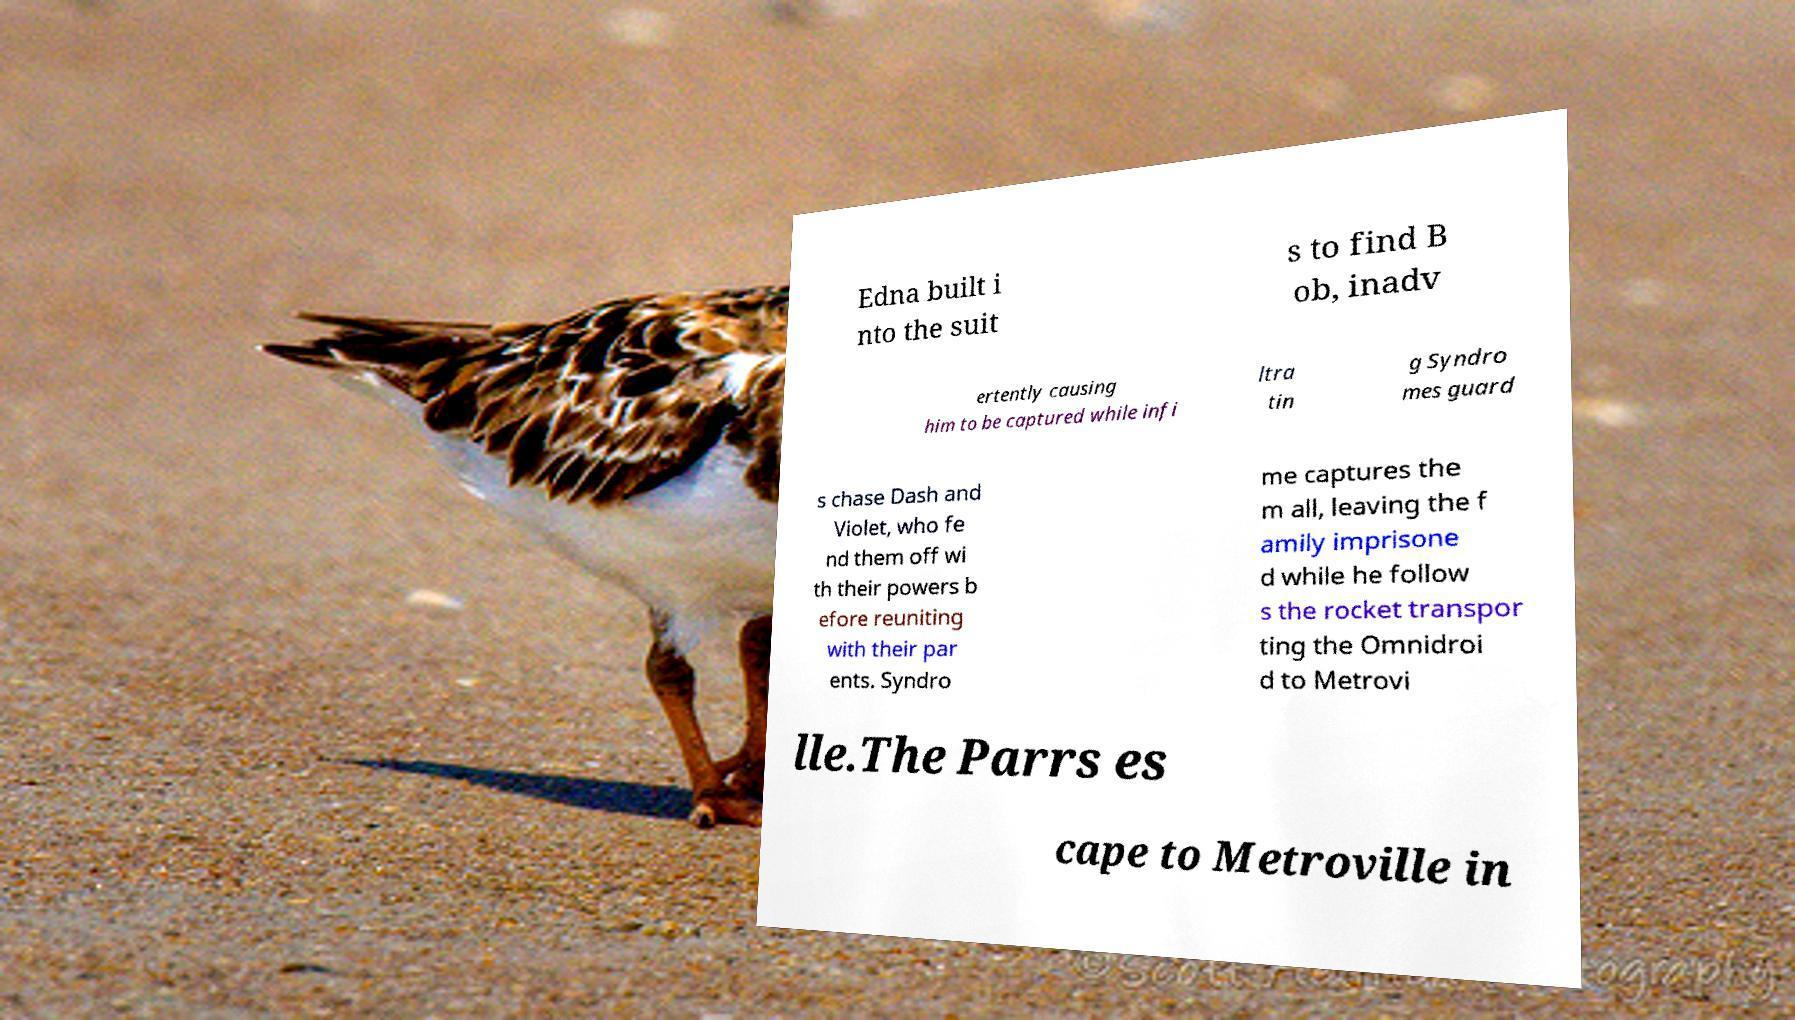For documentation purposes, I need the text within this image transcribed. Could you provide that? Edna built i nto the suit s to find B ob, inadv ertently causing him to be captured while infi ltra tin g Syndro mes guard s chase Dash and Violet, who fe nd them off wi th their powers b efore reuniting with their par ents. Syndro me captures the m all, leaving the f amily imprisone d while he follow s the rocket transpor ting the Omnidroi d to Metrovi lle.The Parrs es cape to Metroville in 